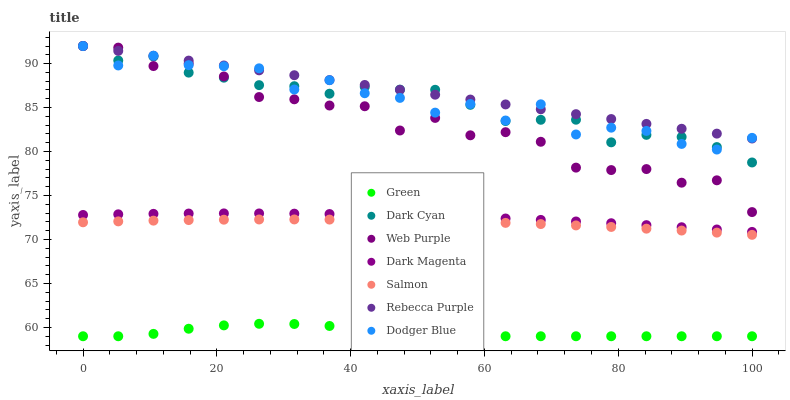Does Green have the minimum area under the curve?
Answer yes or no. Yes. Does Rebecca Purple have the maximum area under the curve?
Answer yes or no. Yes. Does Salmon have the minimum area under the curve?
Answer yes or no. No. Does Salmon have the maximum area under the curve?
Answer yes or no. No. Is Rebecca Purple the smoothest?
Answer yes or no. Yes. Is Dodger Blue the roughest?
Answer yes or no. Yes. Is Salmon the smoothest?
Answer yes or no. No. Is Salmon the roughest?
Answer yes or no. No. Does Green have the lowest value?
Answer yes or no. Yes. Does Salmon have the lowest value?
Answer yes or no. No. Does Dodger Blue have the highest value?
Answer yes or no. Yes. Does Salmon have the highest value?
Answer yes or no. No. Is Salmon less than Dark Magenta?
Answer yes or no. Yes. Is Rebecca Purple greater than Salmon?
Answer yes or no. Yes. Does Dodger Blue intersect Web Purple?
Answer yes or no. Yes. Is Dodger Blue less than Web Purple?
Answer yes or no. No. Is Dodger Blue greater than Web Purple?
Answer yes or no. No. Does Salmon intersect Dark Magenta?
Answer yes or no. No. 